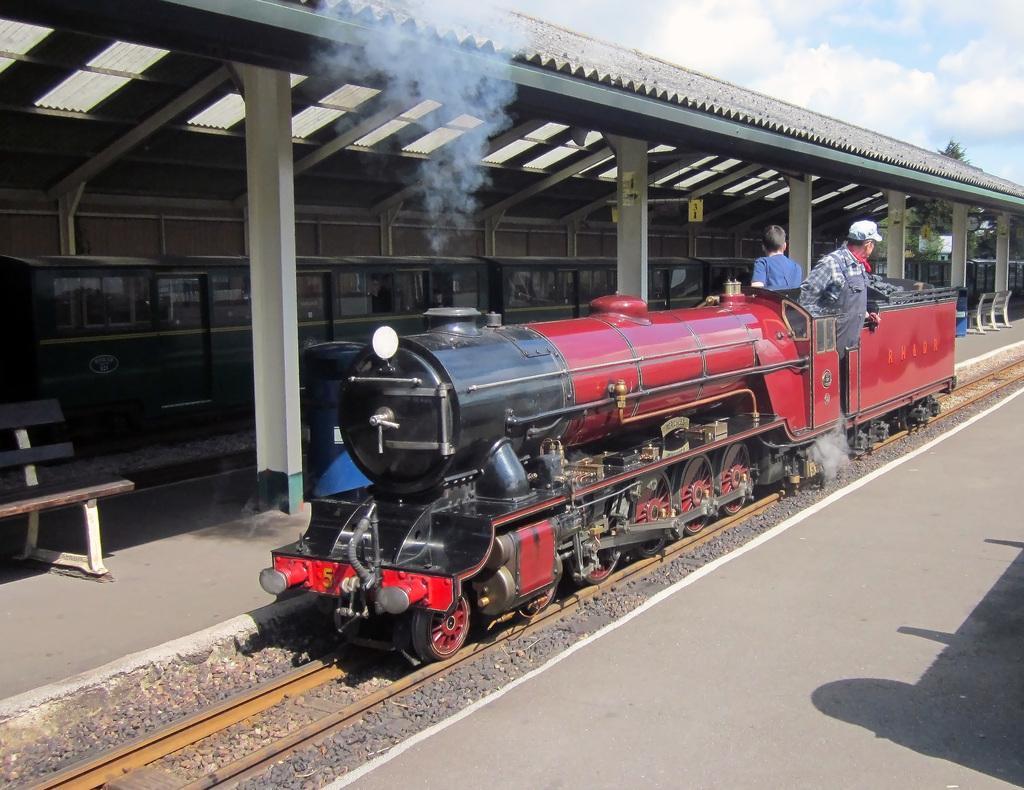How would you summarize this image in a sentence or two? In this image I can see the train on the track. I can see two people on the train. To the side of the train I can see the benches, shed and one more train. In the background I can see the clouds and the sky. 